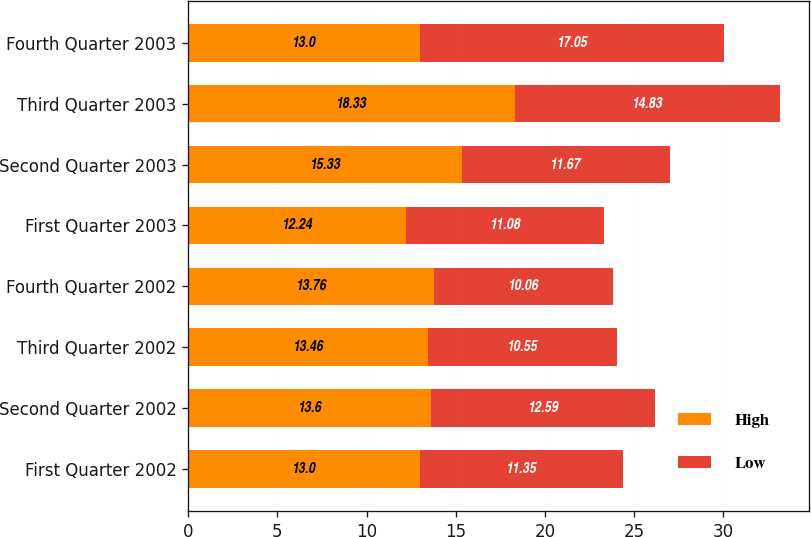Convert chart. <chart><loc_0><loc_0><loc_500><loc_500><stacked_bar_chart><ecel><fcel>First Quarter 2002<fcel>Second Quarter 2002<fcel>Third Quarter 2002<fcel>Fourth Quarter 2002<fcel>First Quarter 2003<fcel>Second Quarter 2003<fcel>Third Quarter 2003<fcel>Fourth Quarter 2003<nl><fcel>High<fcel>13<fcel>13.6<fcel>13.46<fcel>13.76<fcel>12.24<fcel>15.33<fcel>18.33<fcel>13<nl><fcel>Low<fcel>11.35<fcel>12.59<fcel>10.55<fcel>10.06<fcel>11.08<fcel>11.67<fcel>14.83<fcel>17.05<nl></chart> 